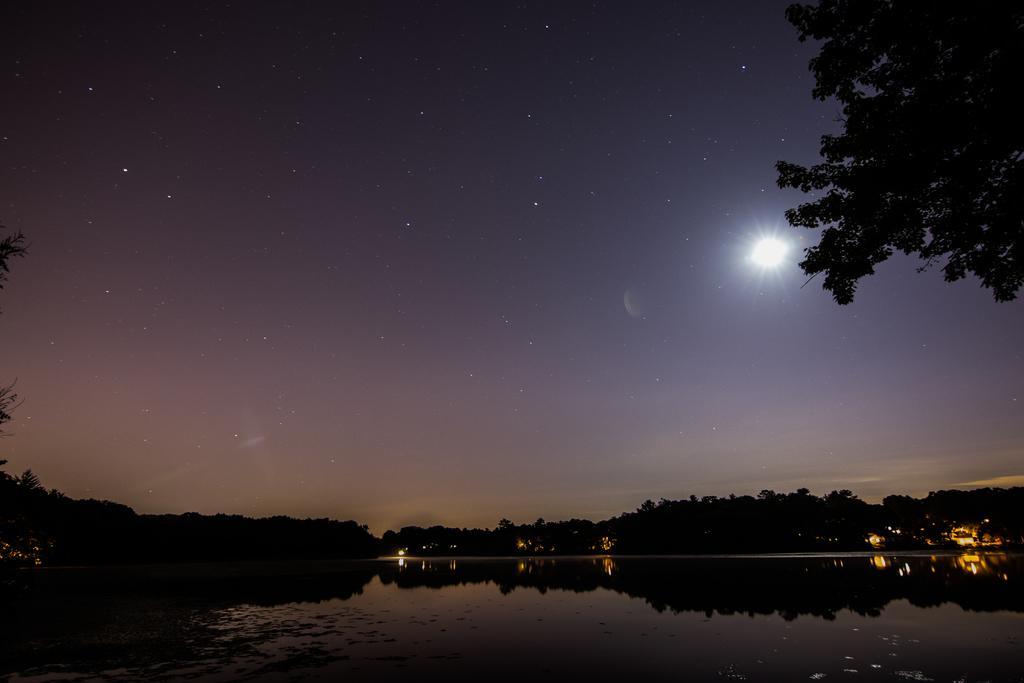Can you describe this image briefly? In this image we can see sky with stars, trees and water. 